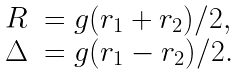<formula> <loc_0><loc_0><loc_500><loc_500>\begin{array} { r l } R & = g ( r _ { 1 } + r _ { 2 } ) / 2 , \\ \Delta & = g ( r _ { 1 } - r _ { 2 } ) / 2 . \end{array}</formula> 